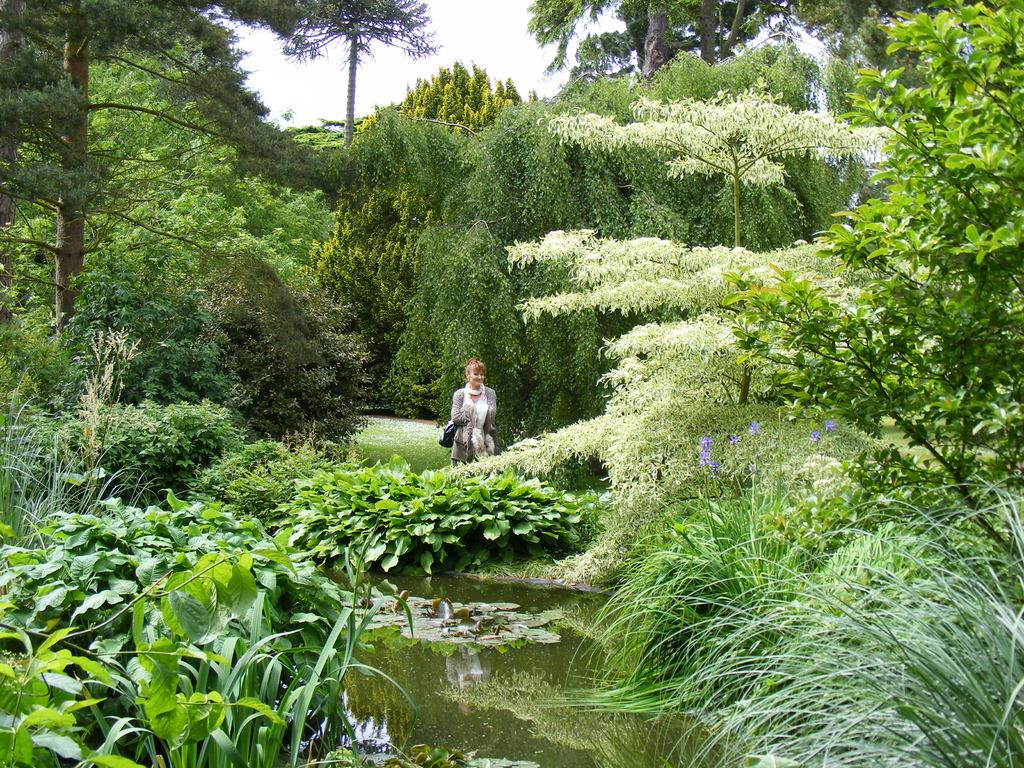What type of natural elements can be seen in the image? There are trees and plants in the image. Can you describe the person in the image? There is a woman in the image. Where is the woman positioned in the image? The woman is in the middle of the image. What is in front of the woman in the image? There is a water surface in front of the woman. What type of birthday event is taking place in the image? There is no indication of a birthday event or celebration in the image. How hot is the temperature in the image? The image does not provide any information about the temperature or weather conditions. 